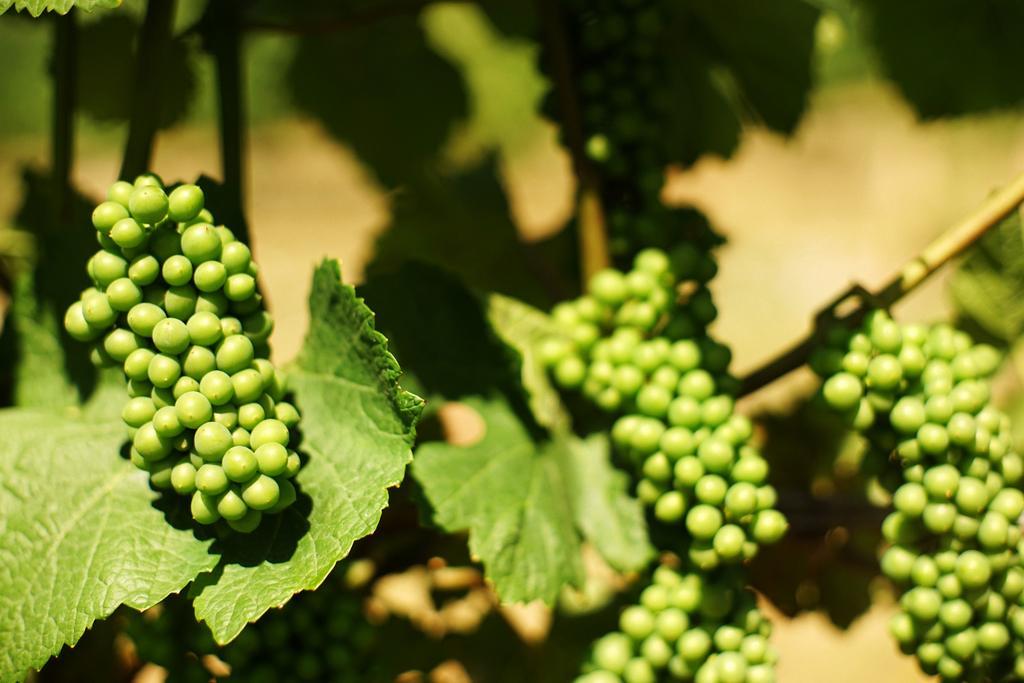Could you give a brief overview of what you see in this image? In this picture I can see there are fruits and they are attached to the stems and there are leafs and the backdrop is blurred. 